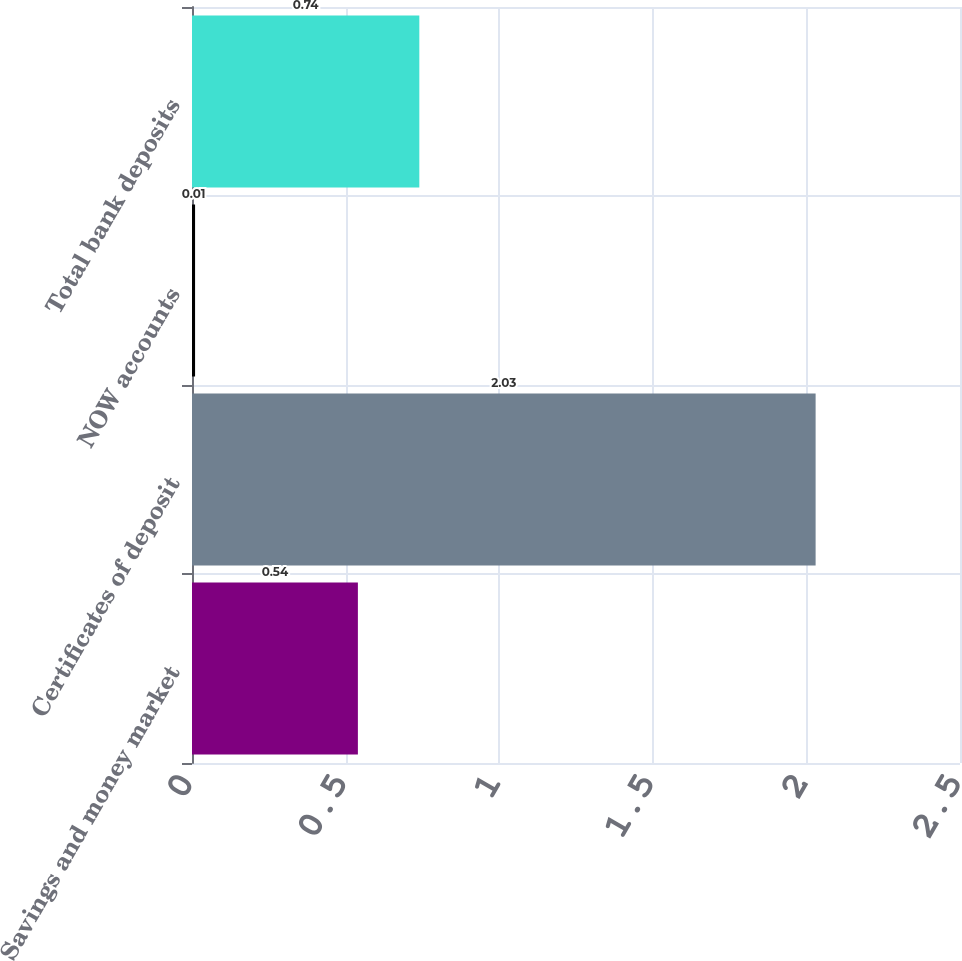Convert chart. <chart><loc_0><loc_0><loc_500><loc_500><bar_chart><fcel>Savings and money market<fcel>Certificates of deposit<fcel>NOW accounts<fcel>Total bank deposits<nl><fcel>0.54<fcel>2.03<fcel>0.01<fcel>0.74<nl></chart> 